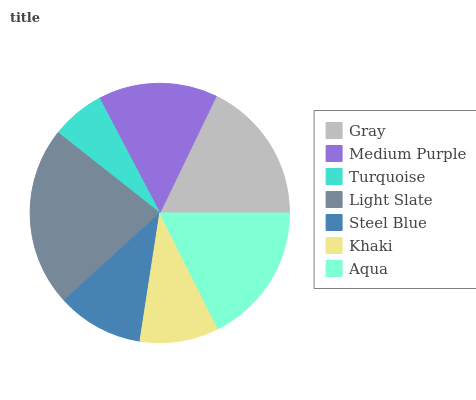Is Turquoise the minimum?
Answer yes or no. Yes. Is Light Slate the maximum?
Answer yes or no. Yes. Is Medium Purple the minimum?
Answer yes or no. No. Is Medium Purple the maximum?
Answer yes or no. No. Is Gray greater than Medium Purple?
Answer yes or no. Yes. Is Medium Purple less than Gray?
Answer yes or no. Yes. Is Medium Purple greater than Gray?
Answer yes or no. No. Is Gray less than Medium Purple?
Answer yes or no. No. Is Medium Purple the high median?
Answer yes or no. Yes. Is Medium Purple the low median?
Answer yes or no. Yes. Is Turquoise the high median?
Answer yes or no. No. Is Turquoise the low median?
Answer yes or no. No. 